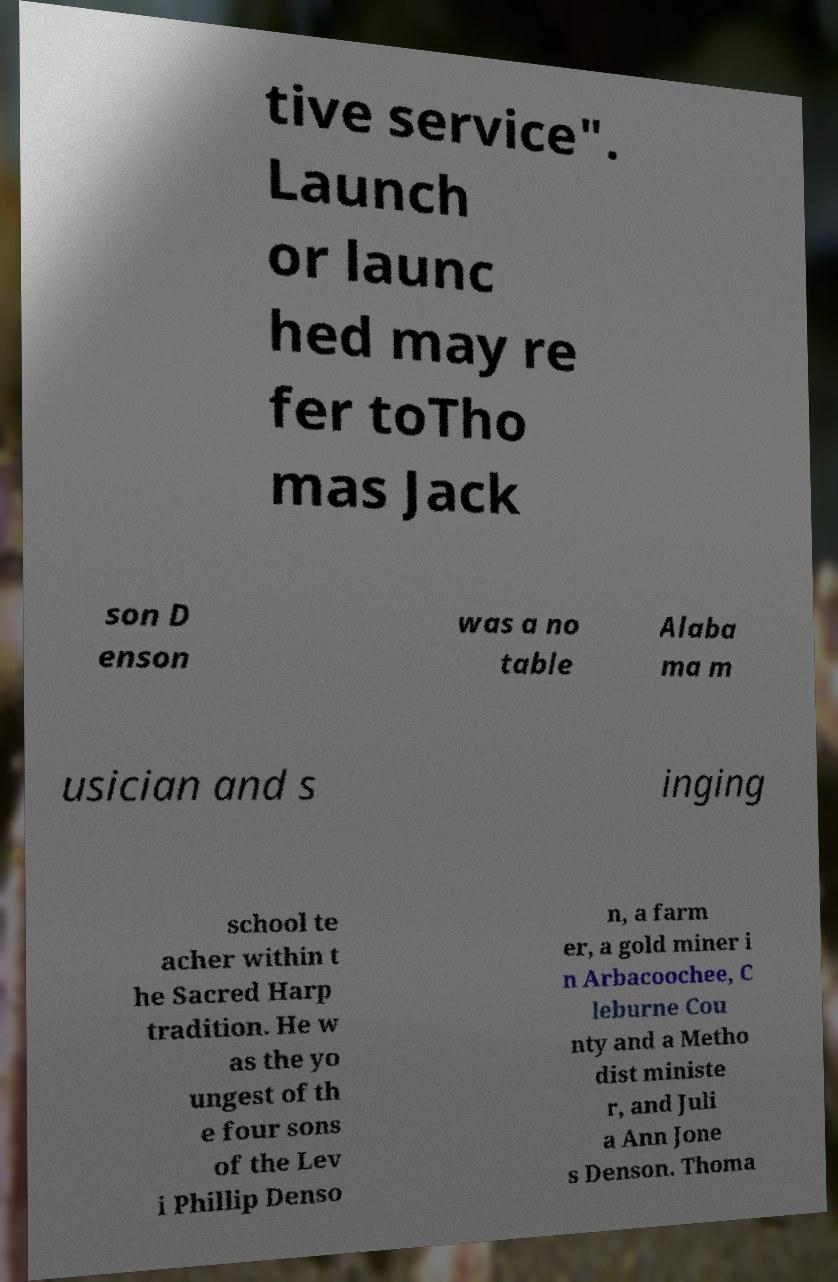What messages or text are displayed in this image? I need them in a readable, typed format. tive service". Launch or launc hed may re fer toTho mas Jack son D enson was a no table Alaba ma m usician and s inging school te acher within t he Sacred Harp tradition. He w as the yo ungest of th e four sons of the Lev i Phillip Denso n, a farm er, a gold miner i n Arbacoochee, C leburne Cou nty and a Metho dist ministe r, and Juli a Ann Jone s Denson. Thoma 